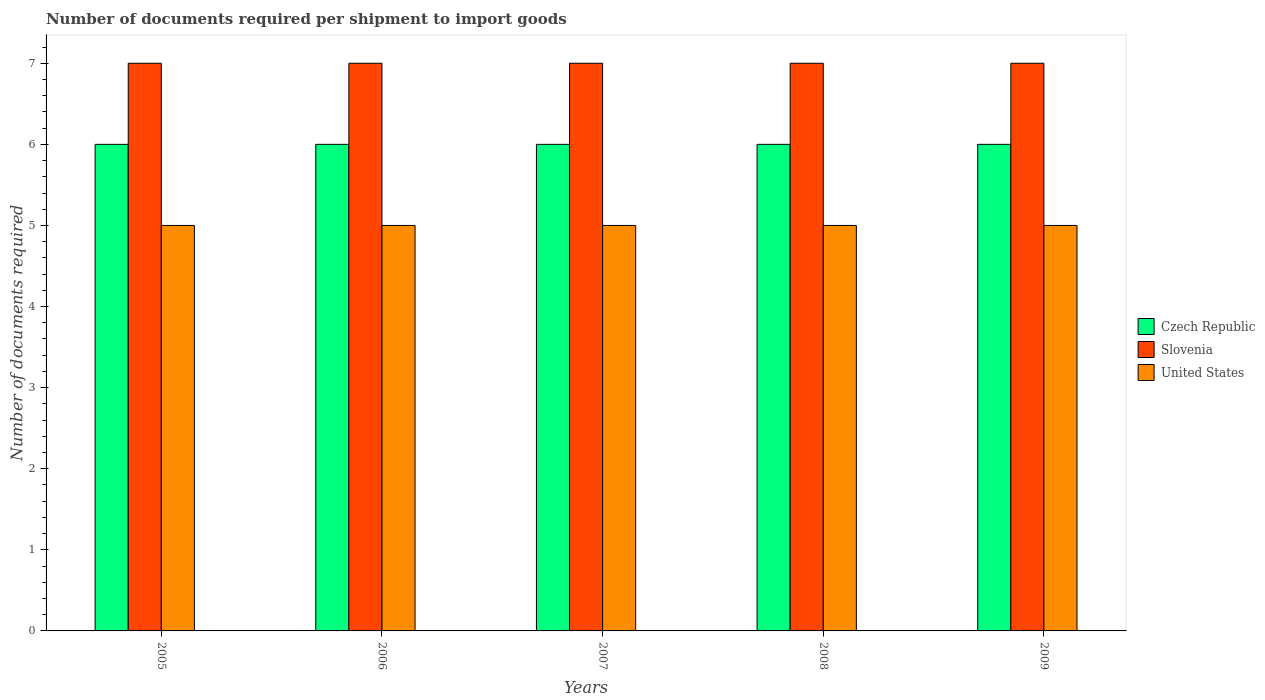How many different coloured bars are there?
Ensure brevity in your answer.  3. How many groups of bars are there?
Ensure brevity in your answer.  5. Are the number of bars per tick equal to the number of legend labels?
Your response must be concise. Yes. How many bars are there on the 5th tick from the right?
Provide a short and direct response. 3. What is the label of the 5th group of bars from the left?
Keep it short and to the point. 2009. What is the number of documents required per shipment to import goods in Czech Republic in 2005?
Provide a succinct answer. 6. Across all years, what is the maximum number of documents required per shipment to import goods in United States?
Your answer should be very brief. 5. Across all years, what is the minimum number of documents required per shipment to import goods in Slovenia?
Your answer should be very brief. 7. In which year was the number of documents required per shipment to import goods in United States maximum?
Make the answer very short. 2005. In which year was the number of documents required per shipment to import goods in United States minimum?
Ensure brevity in your answer.  2005. What is the total number of documents required per shipment to import goods in Czech Republic in the graph?
Your response must be concise. 30. What is the difference between the number of documents required per shipment to import goods in United States in 2005 and that in 2009?
Offer a terse response. 0. What is the difference between the number of documents required per shipment to import goods in United States in 2008 and the number of documents required per shipment to import goods in Czech Republic in 2006?
Offer a very short reply. -1. In the year 2008, what is the difference between the number of documents required per shipment to import goods in Czech Republic and number of documents required per shipment to import goods in United States?
Offer a very short reply. 1. What is the ratio of the number of documents required per shipment to import goods in United States in 2007 to that in 2008?
Provide a succinct answer. 1. Is the difference between the number of documents required per shipment to import goods in Czech Republic in 2008 and 2009 greater than the difference between the number of documents required per shipment to import goods in United States in 2008 and 2009?
Offer a terse response. No. What is the difference between the highest and the second highest number of documents required per shipment to import goods in Slovenia?
Keep it short and to the point. 0. What is the difference between the highest and the lowest number of documents required per shipment to import goods in Slovenia?
Ensure brevity in your answer.  0. In how many years, is the number of documents required per shipment to import goods in United States greater than the average number of documents required per shipment to import goods in United States taken over all years?
Offer a very short reply. 0. What does the 3rd bar from the left in 2005 represents?
Your answer should be compact. United States. Is it the case that in every year, the sum of the number of documents required per shipment to import goods in Czech Republic and number of documents required per shipment to import goods in United States is greater than the number of documents required per shipment to import goods in Slovenia?
Your response must be concise. Yes. How many bars are there?
Your response must be concise. 15. Are the values on the major ticks of Y-axis written in scientific E-notation?
Your response must be concise. No. How many legend labels are there?
Your answer should be very brief. 3. What is the title of the graph?
Your answer should be compact. Number of documents required per shipment to import goods. Does "Macao" appear as one of the legend labels in the graph?
Your answer should be compact. No. What is the label or title of the X-axis?
Offer a terse response. Years. What is the label or title of the Y-axis?
Make the answer very short. Number of documents required. What is the Number of documents required of Slovenia in 2005?
Keep it short and to the point. 7. What is the Number of documents required in Czech Republic in 2006?
Provide a short and direct response. 6. What is the Number of documents required of Slovenia in 2006?
Your response must be concise. 7. What is the Number of documents required in Czech Republic in 2007?
Offer a very short reply. 6. What is the Number of documents required in United States in 2007?
Your answer should be very brief. 5. What is the Number of documents required in Slovenia in 2008?
Your answer should be very brief. 7. What is the Number of documents required of United States in 2008?
Your answer should be very brief. 5. What is the Number of documents required of Czech Republic in 2009?
Make the answer very short. 6. What is the Number of documents required in Slovenia in 2009?
Your response must be concise. 7. Across all years, what is the minimum Number of documents required of United States?
Your answer should be very brief. 5. What is the total Number of documents required of Czech Republic in the graph?
Make the answer very short. 30. What is the total Number of documents required in United States in the graph?
Your answer should be compact. 25. What is the difference between the Number of documents required in United States in 2005 and that in 2006?
Offer a very short reply. 0. What is the difference between the Number of documents required of Czech Republic in 2005 and that in 2007?
Your answer should be compact. 0. What is the difference between the Number of documents required of United States in 2005 and that in 2008?
Provide a short and direct response. 0. What is the difference between the Number of documents required of United States in 2005 and that in 2009?
Offer a terse response. 0. What is the difference between the Number of documents required in Czech Republic in 2006 and that in 2007?
Keep it short and to the point. 0. What is the difference between the Number of documents required in Czech Republic in 2006 and that in 2008?
Your response must be concise. 0. What is the difference between the Number of documents required of Slovenia in 2006 and that in 2008?
Provide a short and direct response. 0. What is the difference between the Number of documents required in United States in 2006 and that in 2008?
Give a very brief answer. 0. What is the difference between the Number of documents required of Czech Republic in 2006 and that in 2009?
Your answer should be compact. 0. What is the difference between the Number of documents required of Slovenia in 2006 and that in 2009?
Your answer should be compact. 0. What is the difference between the Number of documents required in Czech Republic in 2007 and that in 2009?
Keep it short and to the point. 0. What is the difference between the Number of documents required in United States in 2007 and that in 2009?
Offer a very short reply. 0. What is the difference between the Number of documents required of Czech Republic in 2008 and that in 2009?
Ensure brevity in your answer.  0. What is the difference between the Number of documents required of Slovenia in 2008 and that in 2009?
Keep it short and to the point. 0. What is the difference between the Number of documents required of Slovenia in 2005 and the Number of documents required of United States in 2006?
Make the answer very short. 2. What is the difference between the Number of documents required of Czech Republic in 2005 and the Number of documents required of Slovenia in 2007?
Provide a succinct answer. -1. What is the difference between the Number of documents required of Czech Republic in 2005 and the Number of documents required of United States in 2007?
Keep it short and to the point. 1. What is the difference between the Number of documents required in Czech Republic in 2005 and the Number of documents required in Slovenia in 2009?
Provide a succinct answer. -1. What is the difference between the Number of documents required of Czech Republic in 2005 and the Number of documents required of United States in 2009?
Offer a very short reply. 1. What is the difference between the Number of documents required in Slovenia in 2005 and the Number of documents required in United States in 2009?
Keep it short and to the point. 2. What is the difference between the Number of documents required of Czech Republic in 2006 and the Number of documents required of United States in 2007?
Ensure brevity in your answer.  1. What is the difference between the Number of documents required in Slovenia in 2006 and the Number of documents required in United States in 2007?
Offer a very short reply. 2. What is the difference between the Number of documents required of Czech Republic in 2006 and the Number of documents required of Slovenia in 2009?
Ensure brevity in your answer.  -1. What is the difference between the Number of documents required in Czech Republic in 2006 and the Number of documents required in United States in 2009?
Your answer should be very brief. 1. What is the difference between the Number of documents required in Czech Republic in 2007 and the Number of documents required in Slovenia in 2008?
Your response must be concise. -1. What is the difference between the Number of documents required in Czech Republic in 2007 and the Number of documents required in United States in 2008?
Your response must be concise. 1. What is the difference between the Number of documents required of Slovenia in 2007 and the Number of documents required of United States in 2008?
Make the answer very short. 2. What is the difference between the Number of documents required of Czech Republic in 2007 and the Number of documents required of United States in 2009?
Ensure brevity in your answer.  1. What is the difference between the Number of documents required of Czech Republic in 2008 and the Number of documents required of Slovenia in 2009?
Provide a succinct answer. -1. What is the difference between the Number of documents required of Czech Republic in 2008 and the Number of documents required of United States in 2009?
Provide a succinct answer. 1. What is the average Number of documents required in Czech Republic per year?
Make the answer very short. 6. What is the average Number of documents required in United States per year?
Keep it short and to the point. 5. In the year 2005, what is the difference between the Number of documents required of Czech Republic and Number of documents required of Slovenia?
Ensure brevity in your answer.  -1. In the year 2005, what is the difference between the Number of documents required in Czech Republic and Number of documents required in United States?
Provide a succinct answer. 1. In the year 2005, what is the difference between the Number of documents required of Slovenia and Number of documents required of United States?
Offer a terse response. 2. In the year 2006, what is the difference between the Number of documents required in Czech Republic and Number of documents required in Slovenia?
Your answer should be compact. -1. In the year 2007, what is the difference between the Number of documents required of Czech Republic and Number of documents required of Slovenia?
Make the answer very short. -1. In the year 2008, what is the difference between the Number of documents required in Czech Republic and Number of documents required in United States?
Your answer should be very brief. 1. In the year 2008, what is the difference between the Number of documents required of Slovenia and Number of documents required of United States?
Your response must be concise. 2. In the year 2009, what is the difference between the Number of documents required of Czech Republic and Number of documents required of United States?
Give a very brief answer. 1. In the year 2009, what is the difference between the Number of documents required in Slovenia and Number of documents required in United States?
Your answer should be very brief. 2. What is the ratio of the Number of documents required in Czech Republic in 2005 to that in 2006?
Offer a very short reply. 1. What is the ratio of the Number of documents required of Czech Republic in 2005 to that in 2007?
Offer a very short reply. 1. What is the ratio of the Number of documents required in Slovenia in 2005 to that in 2007?
Make the answer very short. 1. What is the ratio of the Number of documents required of United States in 2005 to that in 2007?
Offer a terse response. 1. What is the ratio of the Number of documents required in Slovenia in 2005 to that in 2008?
Ensure brevity in your answer.  1. What is the ratio of the Number of documents required of United States in 2005 to that in 2008?
Provide a short and direct response. 1. What is the ratio of the Number of documents required in Czech Republic in 2005 to that in 2009?
Your answer should be very brief. 1. What is the ratio of the Number of documents required of Slovenia in 2006 to that in 2007?
Offer a terse response. 1. What is the ratio of the Number of documents required in United States in 2006 to that in 2007?
Make the answer very short. 1. What is the ratio of the Number of documents required in Czech Republic in 2006 to that in 2008?
Keep it short and to the point. 1. What is the ratio of the Number of documents required of Slovenia in 2006 to that in 2008?
Your answer should be compact. 1. What is the ratio of the Number of documents required of United States in 2006 to that in 2008?
Provide a short and direct response. 1. What is the ratio of the Number of documents required in Czech Republic in 2006 to that in 2009?
Your answer should be compact. 1. What is the ratio of the Number of documents required of United States in 2006 to that in 2009?
Your answer should be compact. 1. What is the ratio of the Number of documents required in Czech Republic in 2007 to that in 2008?
Offer a terse response. 1. What is the ratio of the Number of documents required of United States in 2007 to that in 2008?
Keep it short and to the point. 1. What is the ratio of the Number of documents required in Slovenia in 2007 to that in 2009?
Offer a terse response. 1. What is the ratio of the Number of documents required in United States in 2007 to that in 2009?
Keep it short and to the point. 1. What is the ratio of the Number of documents required in Slovenia in 2008 to that in 2009?
Ensure brevity in your answer.  1. What is the ratio of the Number of documents required in United States in 2008 to that in 2009?
Offer a very short reply. 1. What is the difference between the highest and the second highest Number of documents required in Czech Republic?
Offer a terse response. 0. What is the difference between the highest and the second highest Number of documents required in Slovenia?
Your answer should be very brief. 0. 